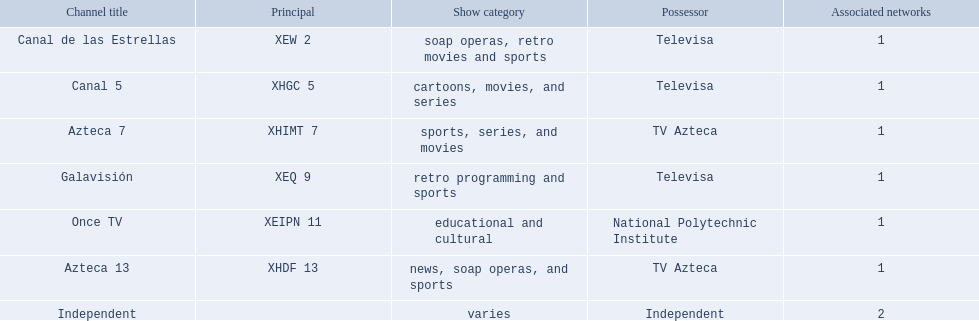What station shows cartoons? Canal 5. What station shows soap operas? Canal de las Estrellas. What station shows sports? Azteca 7. 